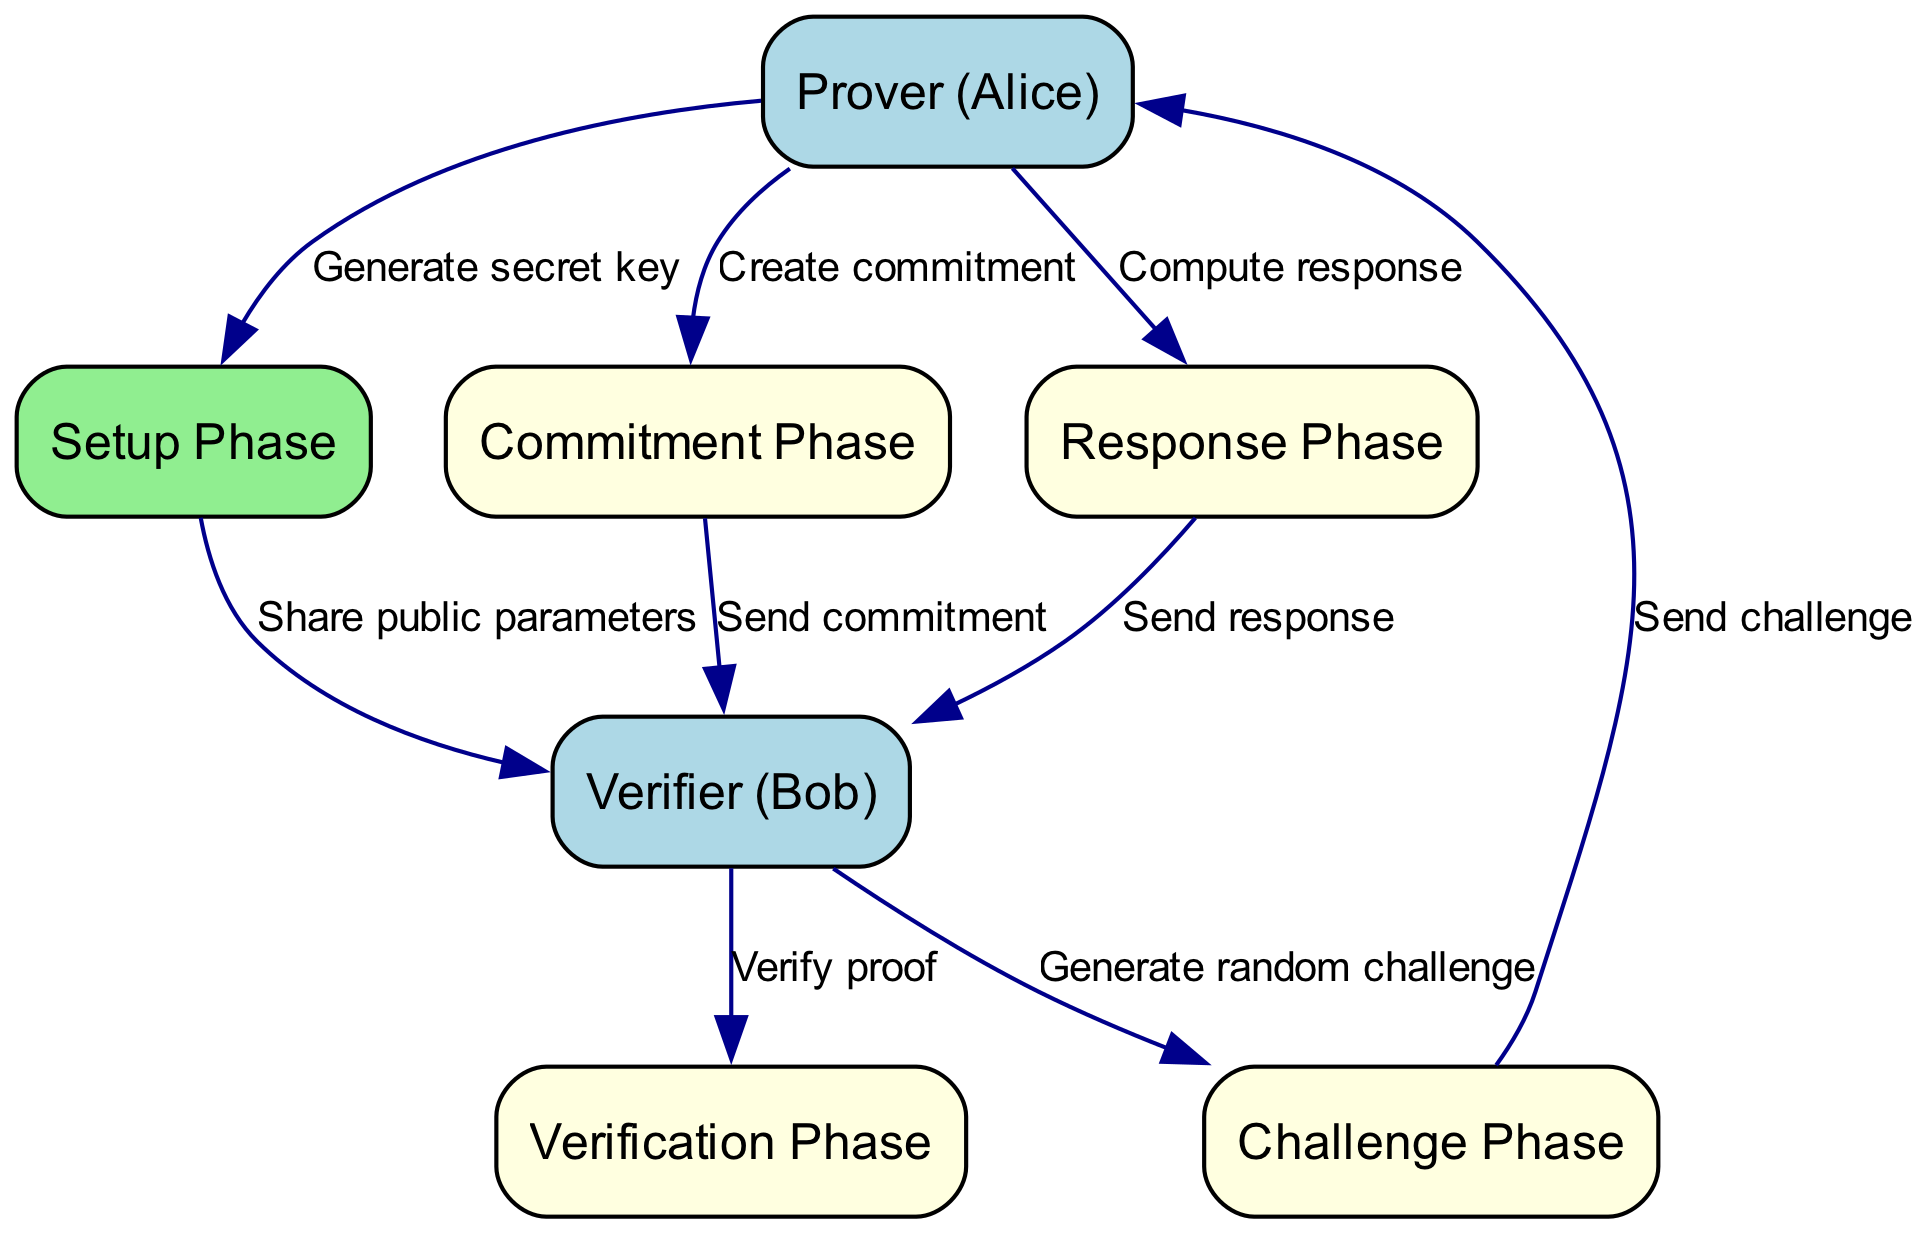What is the total number of nodes in the diagram? The diagram has a total of seven nodes representing different entities and phases in the zero-knowledge proof protocol. This includes the Prover, Verifier, and five distinct phases.
Answer: Seven What are the two main characters in the protocol? The two main characters involved in the protocol are the Prover (Alice) and the Verifier (Bob), as indicated in the nodes section of the diagram.
Answer: Prover and Verifier Which phase follows the Commitment Phase? The phase that follows the Commitment Phase is the Challenge Phase, as shown by the directed edge that transitions from node 4 (Commitment Phase) to node 5 (Challenge Phase).
Answer: Challenge Phase What does Alice do in the Setup Phase? In the Setup Phase, Alice generates a secret key, as indicated by the edge that connects node 1 (Prover) to node 3 (Setup Phase) labeled "Generate secret key."
Answer: Generate secret key What is the relationship between the Verifier and the Commitment Phase? The relationship is that the Verifier receives the commitment from the Prover during the Commitment Phase, as indicated by the directed edge from node 4 (Commitment Phase) to node 2 (Verifier) labeled "Send commitment."
Answer: Send commitment What type of response does Alice compute in the Response Phase? In the Response Phase, Alice computes a response to the challenge received from Bob, as indicated by the edge from node 6 (Response Phase) back to node 1 (Prover), labeled "Compute response."
Answer: Response to challenge During which phase does Bob generate a random challenge? Bob generates a random challenge during the Challenge Phase, as shown by the edge that transitions from node 2 (Verifier) to node 5 (Challenge Phase), labeled "Generate random challenge."
Answer: Challenge Phase What is the final phase of the protocol? The final phase of the protocol is the Verification Phase, which is the last step where Bob verifies the proof provided by Alice, indicated by the edge leading from node 6 (Response Phase) to node 7 (Verification Phase).
Answer: Verification Phase How many directed edges are there in the diagram? The diagram has a total of eight directed edges, representing the flow of actions and communications between the nodes.
Answer: Eight 